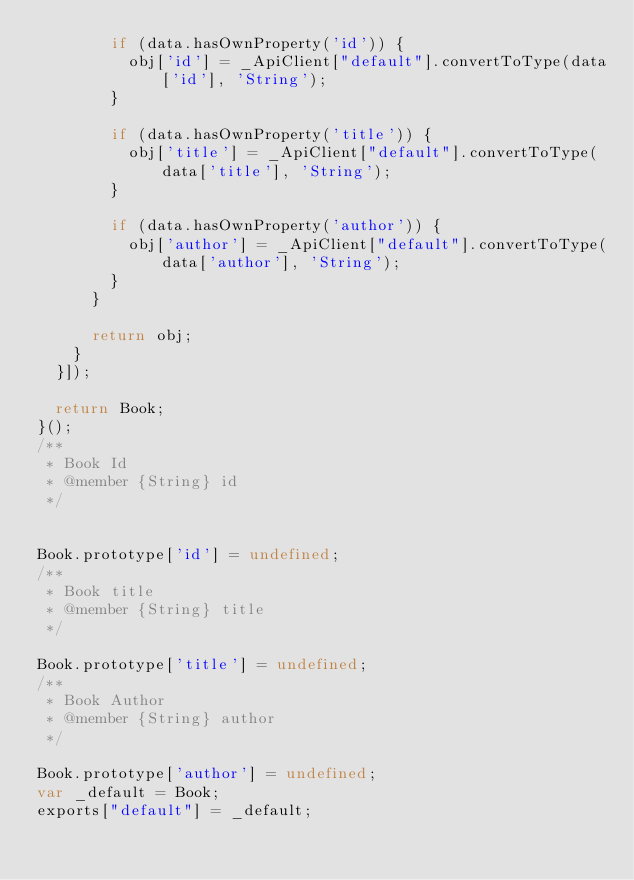Convert code to text. <code><loc_0><loc_0><loc_500><loc_500><_JavaScript_>        if (data.hasOwnProperty('id')) {
          obj['id'] = _ApiClient["default"].convertToType(data['id'], 'String');
        }

        if (data.hasOwnProperty('title')) {
          obj['title'] = _ApiClient["default"].convertToType(data['title'], 'String');
        }

        if (data.hasOwnProperty('author')) {
          obj['author'] = _ApiClient["default"].convertToType(data['author'], 'String');
        }
      }

      return obj;
    }
  }]);

  return Book;
}();
/**
 * Book Id
 * @member {String} id
 */


Book.prototype['id'] = undefined;
/**
 * Book title
 * @member {String} title
 */

Book.prototype['title'] = undefined;
/**
 * Book Author
 * @member {String} author
 */

Book.prototype['author'] = undefined;
var _default = Book;
exports["default"] = _default;</code> 